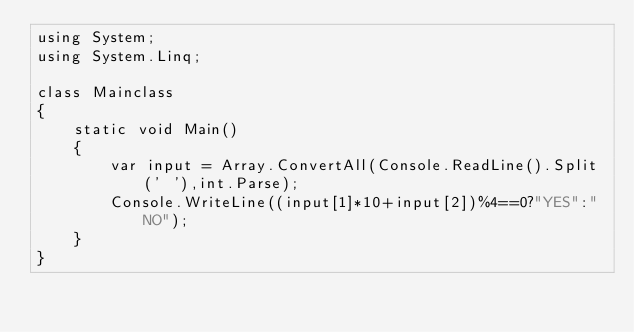Convert code to text. <code><loc_0><loc_0><loc_500><loc_500><_C#_>using System;
using System.Linq;

class Mainclass 
{
    static void Main()
    {
        var input = Array.ConvertAll(Console.ReadLine().Split(' '),int.Parse);
        Console.WriteLine((input[1]*10+input[2])%4==0?"YES":"NO");
    }
}</code> 